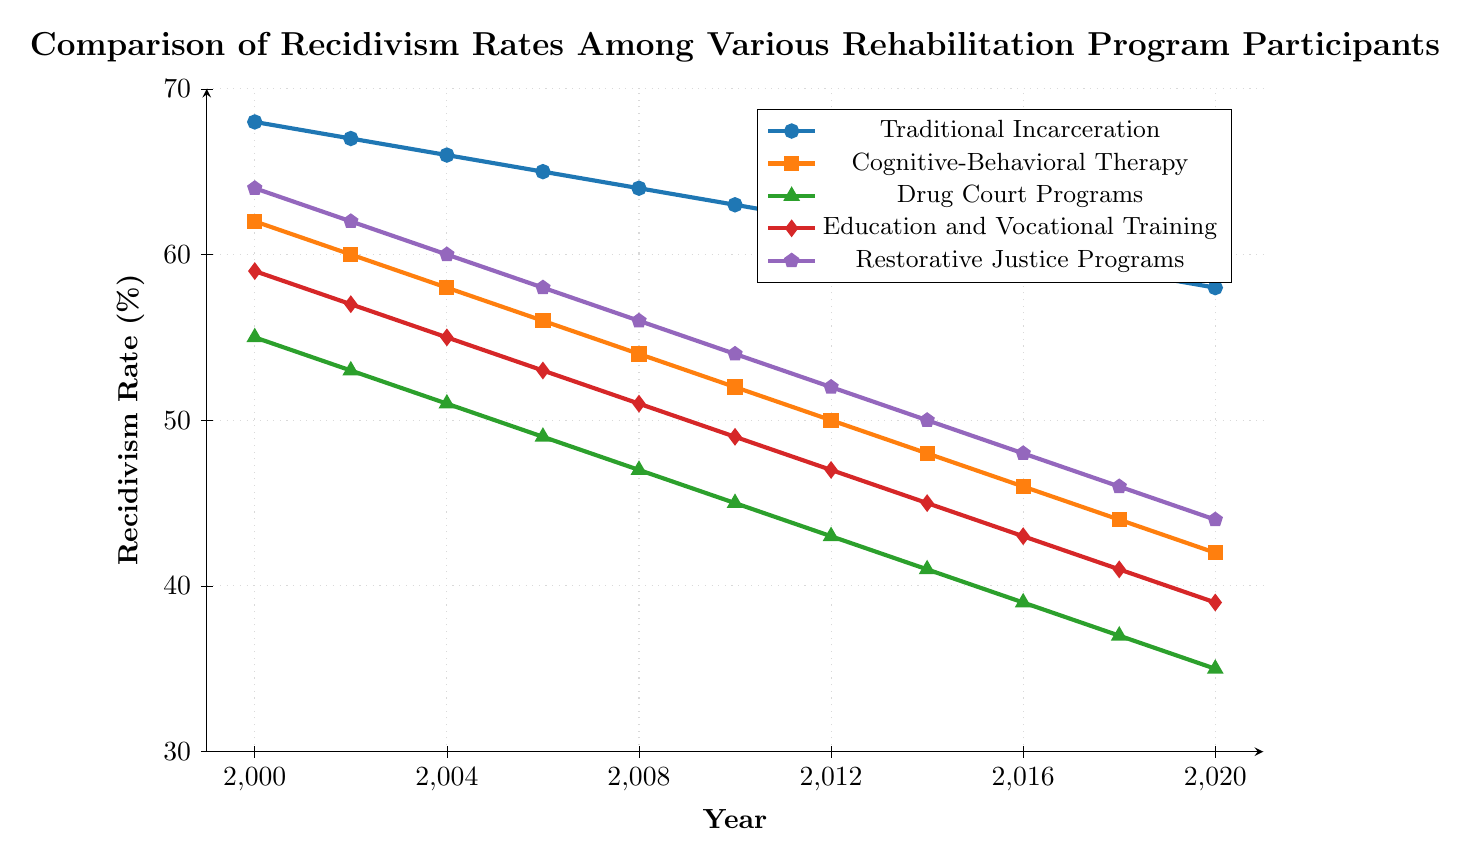What trend is observed in recidivism rates for Traditional Incarceration from 2000 to 2020? The recidivism rates for Traditional Incarceration show a steady decline from 68% in 2000 to 58% in 2020. This trend indicates a gradual decrease in recidivism rates over the 20-year period.
Answer: Steady decline Which rehabilitation program had the lowest recidivism rate in 2020? To determine the lowest recidivism rate in 2020, compare the data points for all programs in that year: Traditional Incarceration (58%), Cognitive-Behavioral Therapy (42%), Drug Court Programs (35%), Education and Vocational Training (39%), and Restorative Justice Programs (44%). The lowest rate is 35% for Drug Court Programs.
Answer: Drug Court Programs Between which two years did Restorative Justice Programs see the most significant decrease in recidivism rates? Analyzing the data points for Restorative Justice Programs, the years with the most significant decrease occur between 2000 and 2002, and 2004 and 2006. The largest drop of 2% is between 2004 (60%) and 2006 (58%).
Answer: 2004 and 2006 How much did the recidivism rate decrease for Cognitive-Behavioral Therapy from 2000 to 2020? The recidivism rate for Cognitive-Behavioral Therapy was 62% in 2000 and 42% in 2020. The decrease is calculated as 62% - 42% = 20%.
Answer: 20% In which year did Education and Vocational Training reach a recidivism rate below 50% for the first time? Observing the data for Education and Vocational Training shows that the recidivism rate dropped below 50% for the first time in 2012, with a rate of 47%.
Answer: 2012 Among the five rehabilitation programs, which displayed the most consistent decline in recidivism rates over the 20-year period? To assess consistency, observe the frequency and magnitude of changes. Drug Court Programs show a consistent decline without any increases, with recidivism rates descending steadily from 55% in 2000 to 35% in 2020.
Answer: Drug Court Programs By how much did the recidivism rate for Traditional Incarceration change over the entire period? The recidivism rate for Traditional Incarceration decreased from 68% in 2000 to 58% in 2020. The change is 68% - 58% = 10%.
Answer: 10% Were recidivism rates for any programs equal at any point in time? Comparing the data points of all programs year by year, there are no instances where the recidivism rates for two different programs are equal at the same time.
Answer: No 